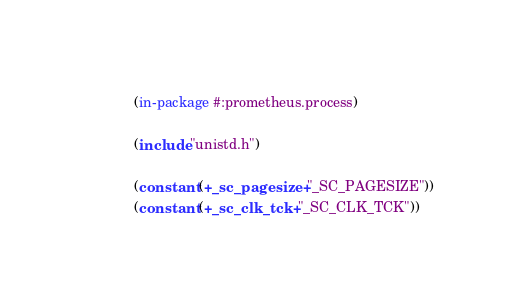<code> <loc_0><loc_0><loc_500><loc_500><_Lisp_>(in-package #:prometheus.process)

(include "unistd.h")

(constant (+_sc_pagesize+ "_SC_PAGESIZE"))
(constant (+_sc_clk_tck+ "_SC_CLK_TCK"))
</code> 